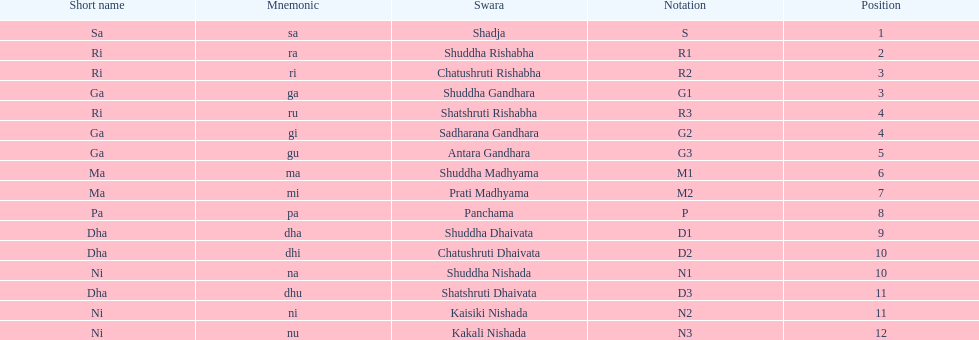On average how many of the swara have a short name that begin with d or g? 6. 